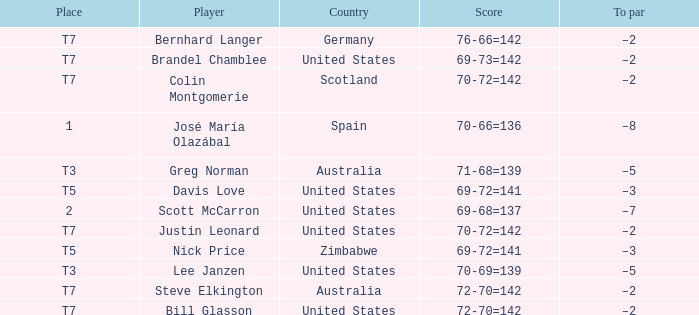WHich Place has a To par of –2, and a Player of bernhard langer? T7. 